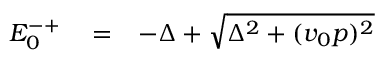Convert formula to latex. <formula><loc_0><loc_0><loc_500><loc_500>\begin{array} { r l r } { E _ { 0 } ^ { - + } } & = } & { - \Delta + \sqrt { \Delta ^ { 2 } + ( v _ { 0 } p ) ^ { 2 } } } \end{array}</formula> 